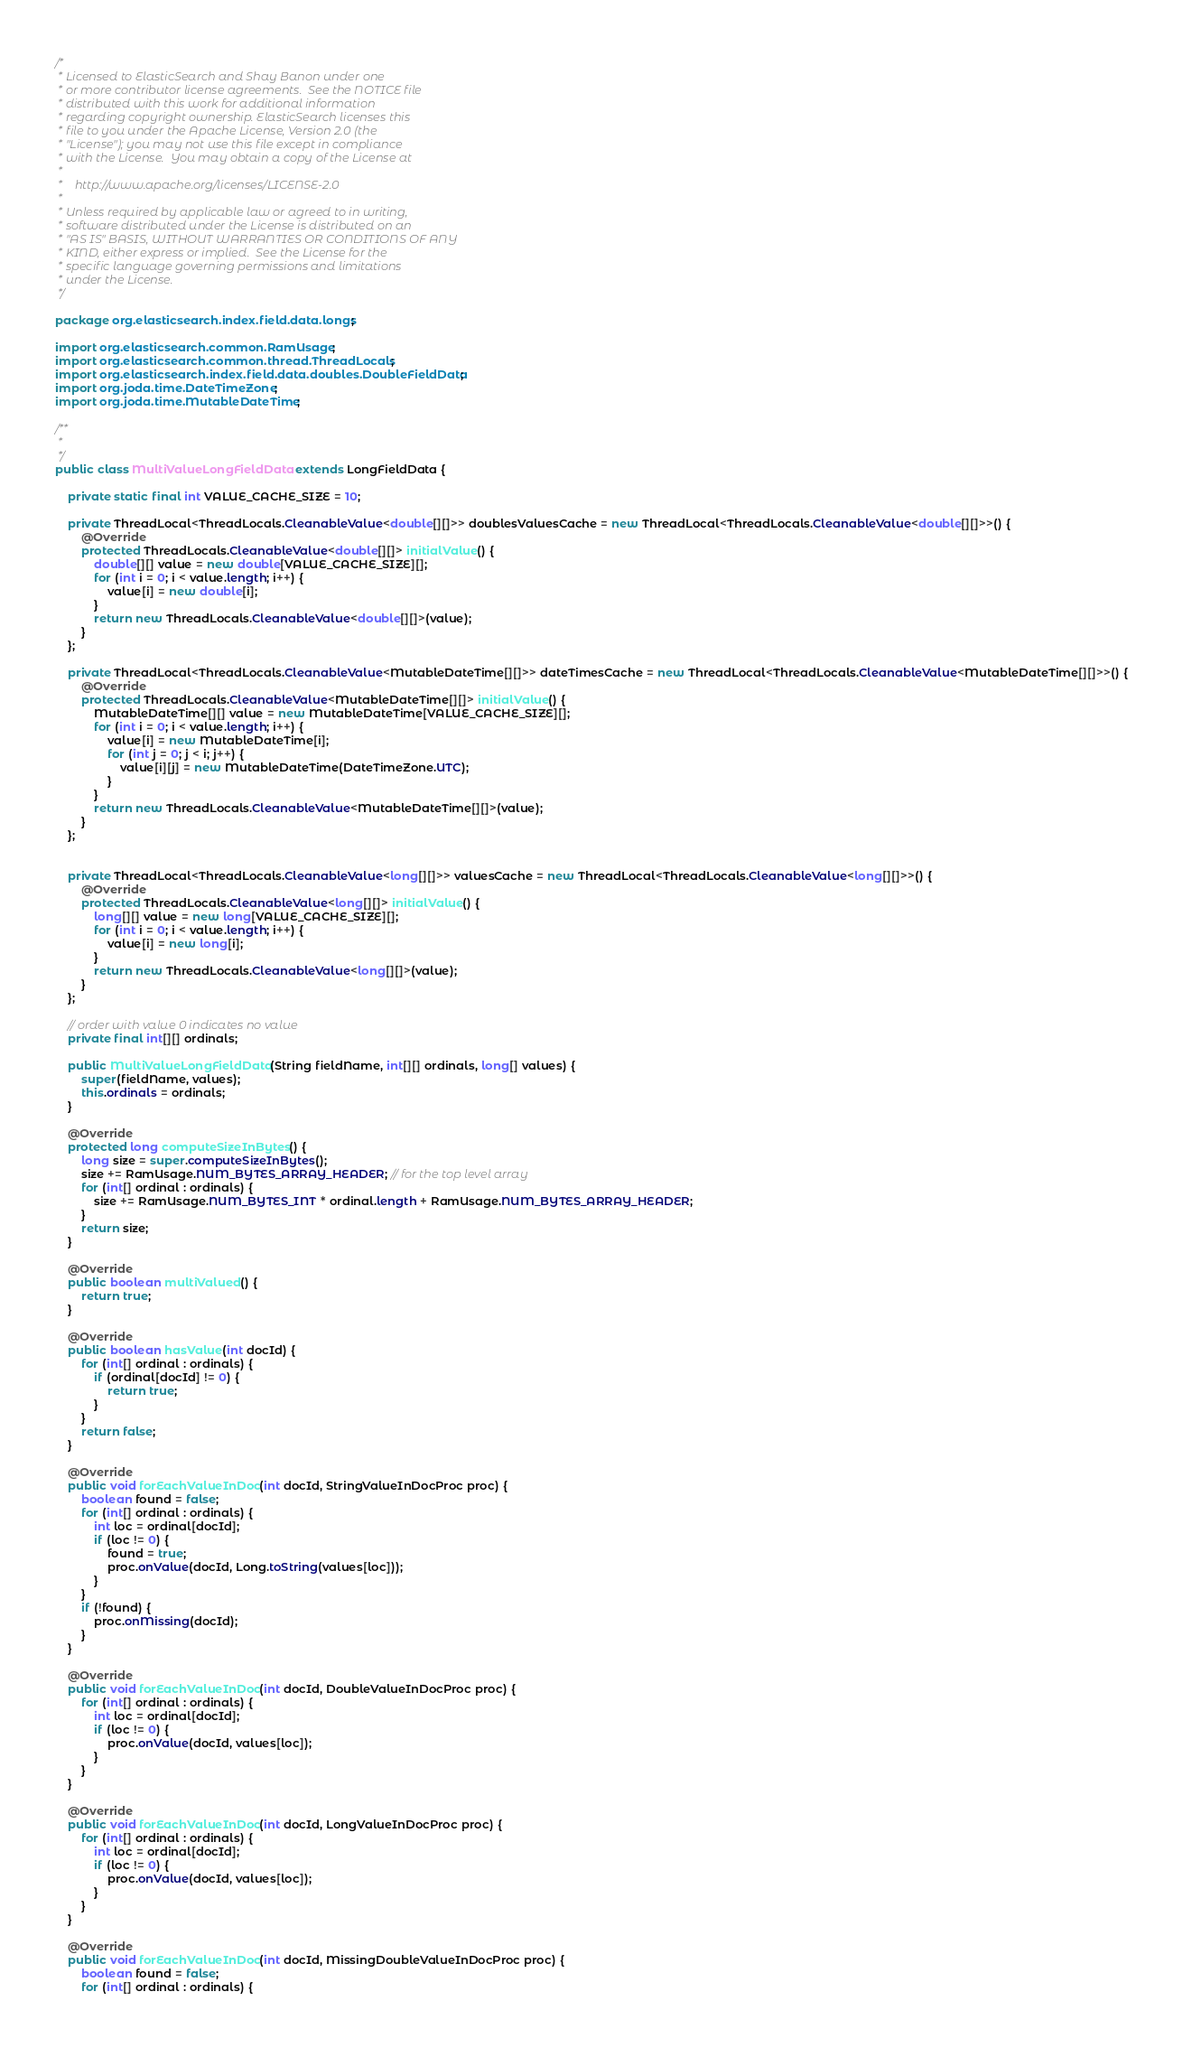<code> <loc_0><loc_0><loc_500><loc_500><_Java_>/*
 * Licensed to ElasticSearch and Shay Banon under one
 * or more contributor license agreements.  See the NOTICE file
 * distributed with this work for additional information
 * regarding copyright ownership. ElasticSearch licenses this
 * file to you under the Apache License, Version 2.0 (the
 * "License"); you may not use this file except in compliance
 * with the License.  You may obtain a copy of the License at
 *
 *    http://www.apache.org/licenses/LICENSE-2.0
 *
 * Unless required by applicable law or agreed to in writing,
 * software distributed under the License is distributed on an
 * "AS IS" BASIS, WITHOUT WARRANTIES OR CONDITIONS OF ANY
 * KIND, either express or implied.  See the License for the
 * specific language governing permissions and limitations
 * under the License.
 */

package org.elasticsearch.index.field.data.longs;

import org.elasticsearch.common.RamUsage;
import org.elasticsearch.common.thread.ThreadLocals;
import org.elasticsearch.index.field.data.doubles.DoubleFieldData;
import org.joda.time.DateTimeZone;
import org.joda.time.MutableDateTime;

/**
 *
 */
public class MultiValueLongFieldData extends LongFieldData {

    private static final int VALUE_CACHE_SIZE = 10;

    private ThreadLocal<ThreadLocals.CleanableValue<double[][]>> doublesValuesCache = new ThreadLocal<ThreadLocals.CleanableValue<double[][]>>() {
        @Override
        protected ThreadLocals.CleanableValue<double[][]> initialValue() {
            double[][] value = new double[VALUE_CACHE_SIZE][];
            for (int i = 0; i < value.length; i++) {
                value[i] = new double[i];
            }
            return new ThreadLocals.CleanableValue<double[][]>(value);
        }
    };

    private ThreadLocal<ThreadLocals.CleanableValue<MutableDateTime[][]>> dateTimesCache = new ThreadLocal<ThreadLocals.CleanableValue<MutableDateTime[][]>>() {
        @Override
        protected ThreadLocals.CleanableValue<MutableDateTime[][]> initialValue() {
            MutableDateTime[][] value = new MutableDateTime[VALUE_CACHE_SIZE][];
            for (int i = 0; i < value.length; i++) {
                value[i] = new MutableDateTime[i];
                for (int j = 0; j < i; j++) {
                    value[i][j] = new MutableDateTime(DateTimeZone.UTC);
                }
            }
            return new ThreadLocals.CleanableValue<MutableDateTime[][]>(value);
        }
    };


    private ThreadLocal<ThreadLocals.CleanableValue<long[][]>> valuesCache = new ThreadLocal<ThreadLocals.CleanableValue<long[][]>>() {
        @Override
        protected ThreadLocals.CleanableValue<long[][]> initialValue() {
            long[][] value = new long[VALUE_CACHE_SIZE][];
            for (int i = 0; i < value.length; i++) {
                value[i] = new long[i];
            }
            return new ThreadLocals.CleanableValue<long[][]>(value);
        }
    };

    // order with value 0 indicates no value
    private final int[][] ordinals;

    public MultiValueLongFieldData(String fieldName, int[][] ordinals, long[] values) {
        super(fieldName, values);
        this.ordinals = ordinals;
    }

    @Override
    protected long computeSizeInBytes() {
        long size = super.computeSizeInBytes();
        size += RamUsage.NUM_BYTES_ARRAY_HEADER; // for the top level array
        for (int[] ordinal : ordinals) {
            size += RamUsage.NUM_BYTES_INT * ordinal.length + RamUsage.NUM_BYTES_ARRAY_HEADER;
        }
        return size;
    }

    @Override
    public boolean multiValued() {
        return true;
    }

    @Override
    public boolean hasValue(int docId) {
        for (int[] ordinal : ordinals) {
            if (ordinal[docId] != 0) {
                return true;
            }
        }
        return false;
    }

    @Override
    public void forEachValueInDoc(int docId, StringValueInDocProc proc) {
        boolean found = false;
        for (int[] ordinal : ordinals) {
            int loc = ordinal[docId];
            if (loc != 0) {
                found = true;
                proc.onValue(docId, Long.toString(values[loc]));
            }
        }
        if (!found) {
            proc.onMissing(docId);
        }
    }

    @Override
    public void forEachValueInDoc(int docId, DoubleValueInDocProc proc) {
        for (int[] ordinal : ordinals) {
            int loc = ordinal[docId];
            if (loc != 0) {
                proc.onValue(docId, values[loc]);
            }
        }
    }

    @Override
    public void forEachValueInDoc(int docId, LongValueInDocProc proc) {
        for (int[] ordinal : ordinals) {
            int loc = ordinal[docId];
            if (loc != 0) {
                proc.onValue(docId, values[loc]);
            }
        }
    }

    @Override
    public void forEachValueInDoc(int docId, MissingDoubleValueInDocProc proc) {
        boolean found = false;
        for (int[] ordinal : ordinals) {</code> 